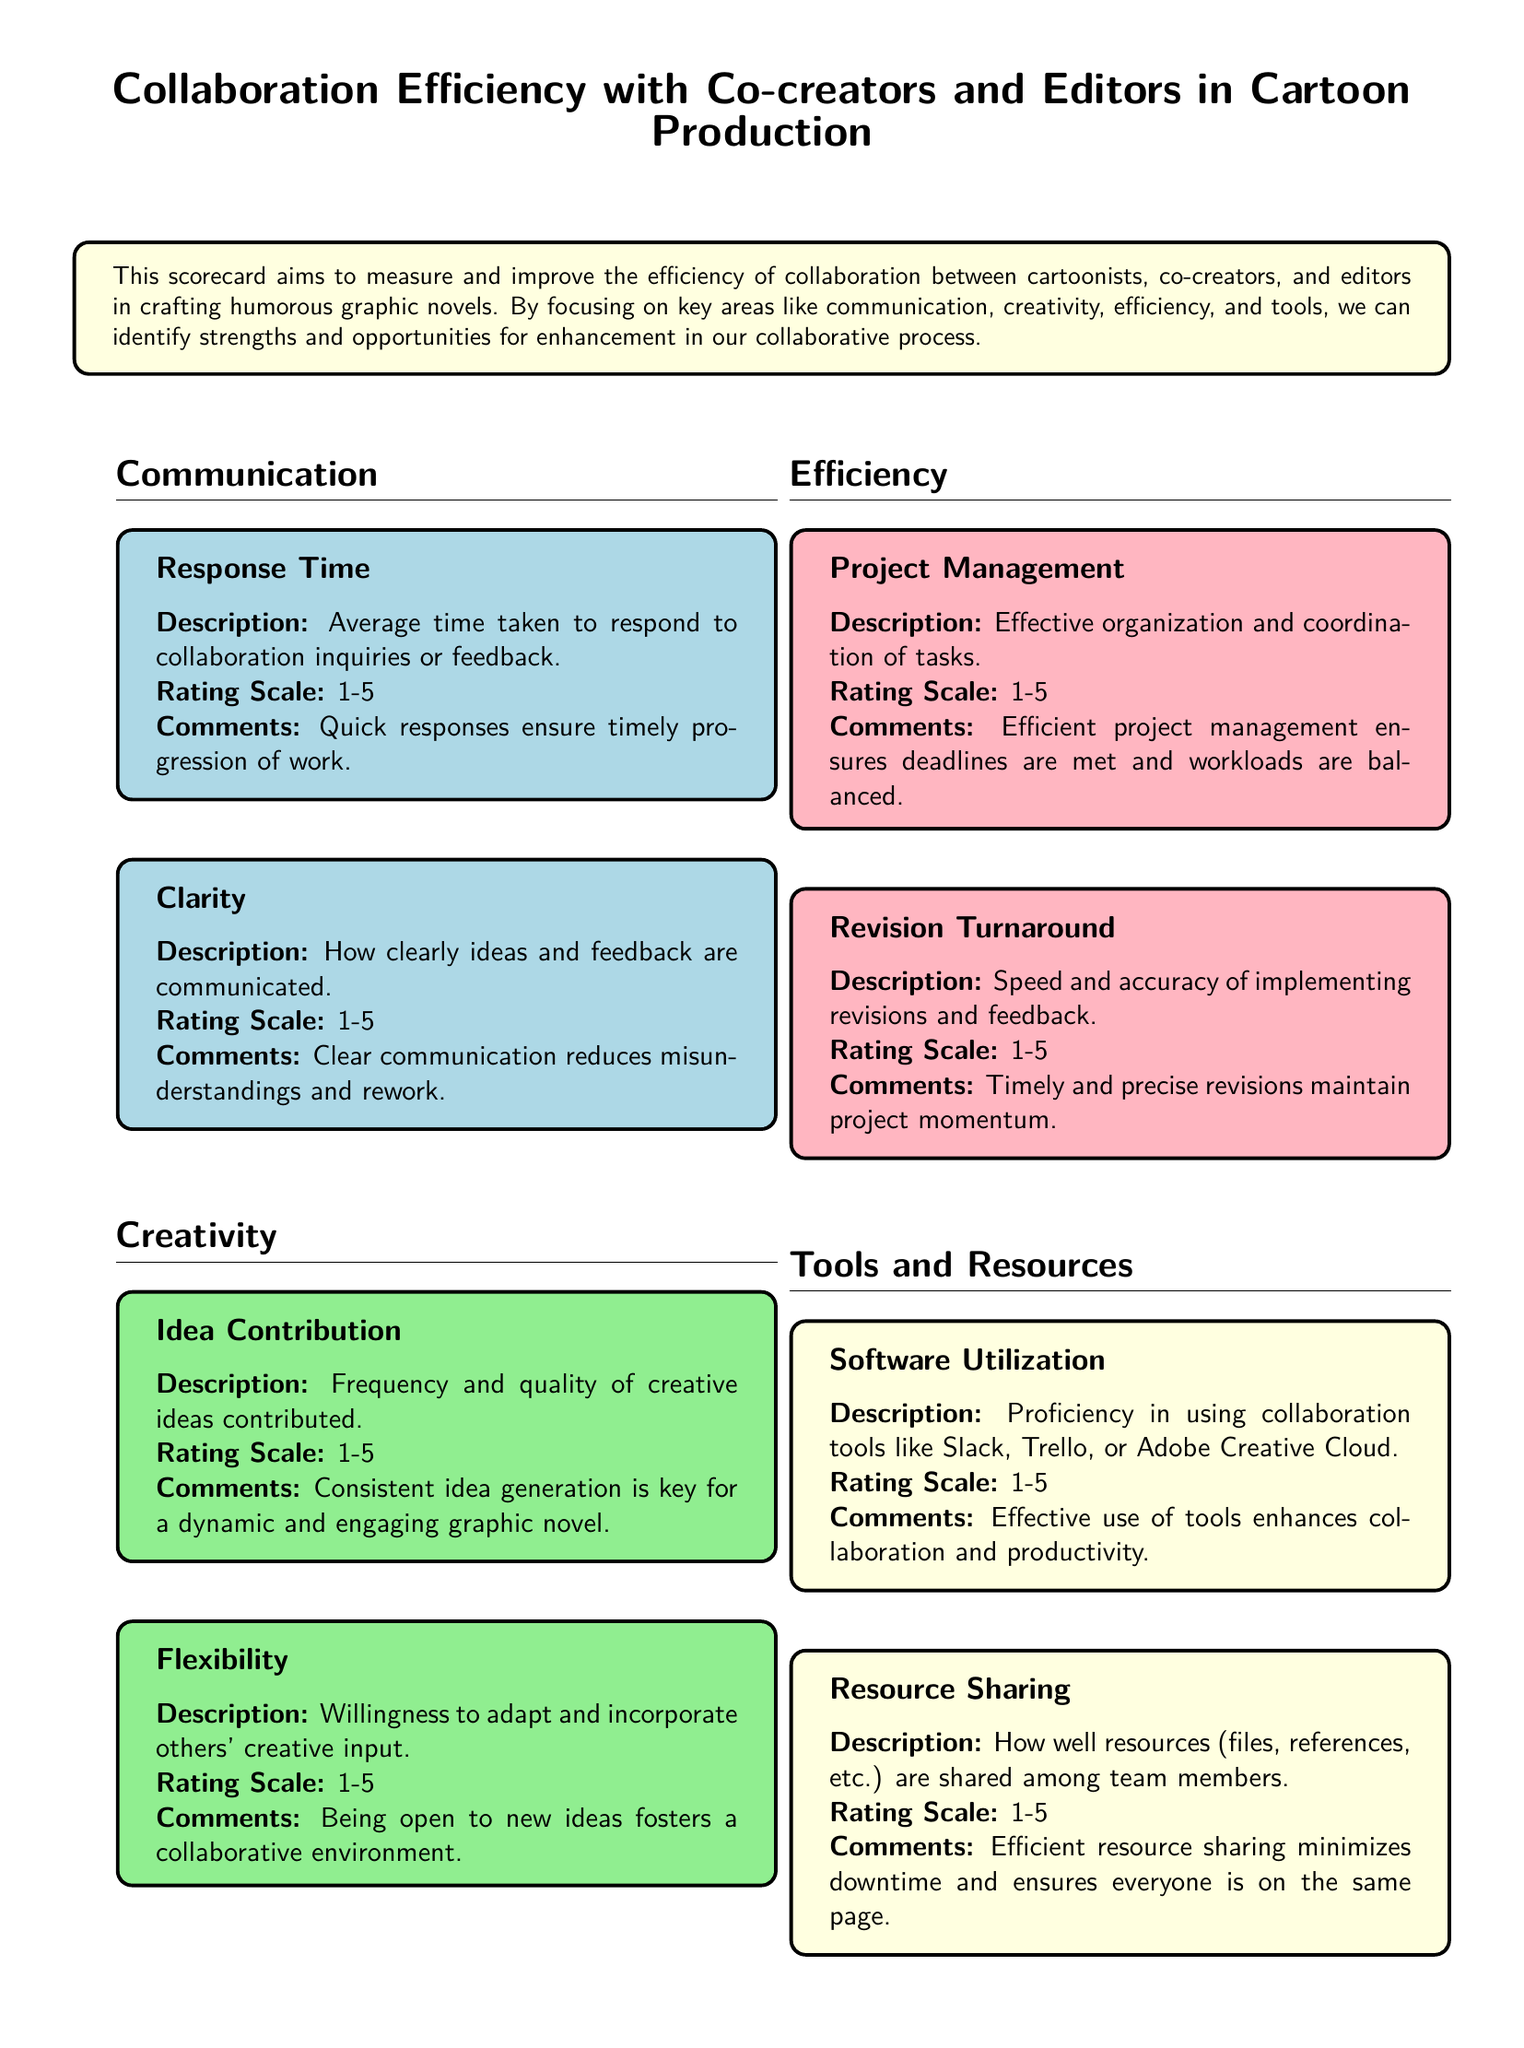what is the main purpose of the scorecard? The main purpose of the scorecard is to measure and improve the efficiency of collaboration between cartoonists, co-creators, and editors in crafting humorous graphic novels.
Answer: measure and improve collaboration efficiency how many areas are evaluated in the scorecard? The scorecard evaluates four key areas: Communication, Creativity, Efficiency, and Tools and Resources.
Answer: four what is the rating scale used in the scorecard? The rating scale for the scorecard is from 1 to 5.
Answer: 1-5 what is assessed under the section of Clarity? The Clarity section assesses how clearly ideas and feedback are communicated.
Answer: clear communication which area focuses on the proficiency of collaboration tools? The area that focuses on the proficiency of collaboration tools is Tools and Resources.
Answer: Tools and Resources what does the Revision Turnaround section measure? The Revision Turnaround section measures the speed and accuracy of implementing revisions and feedback.
Answer: speed and accuracy of revisions how is Idea Contribution evaluated? Idea Contribution is evaluated based on the frequency and quality of creative ideas contributed.
Answer: frequency and quality of ideas what color is used for the Communication section? The color used for the Communication section is light blue.
Answer: light blue 